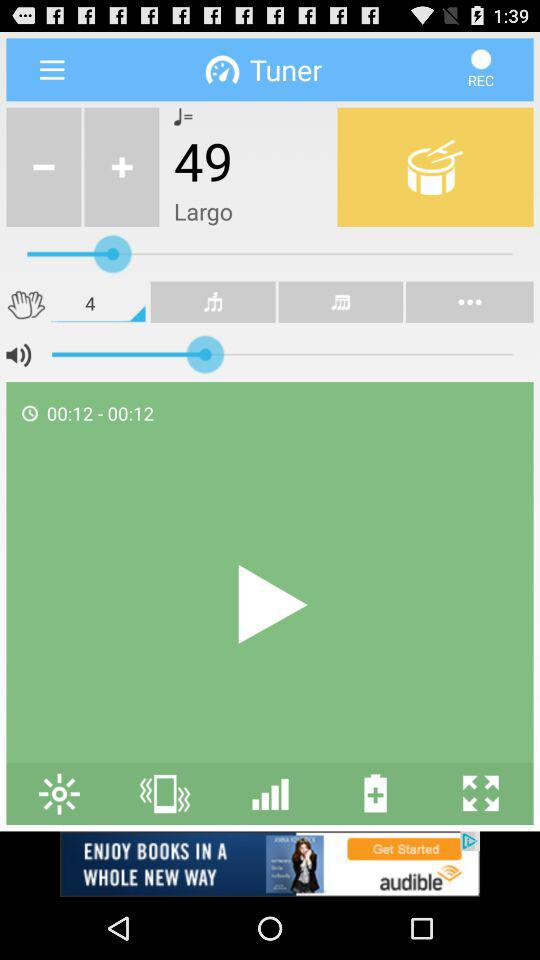What is the application name? The application name is "Tuner". 